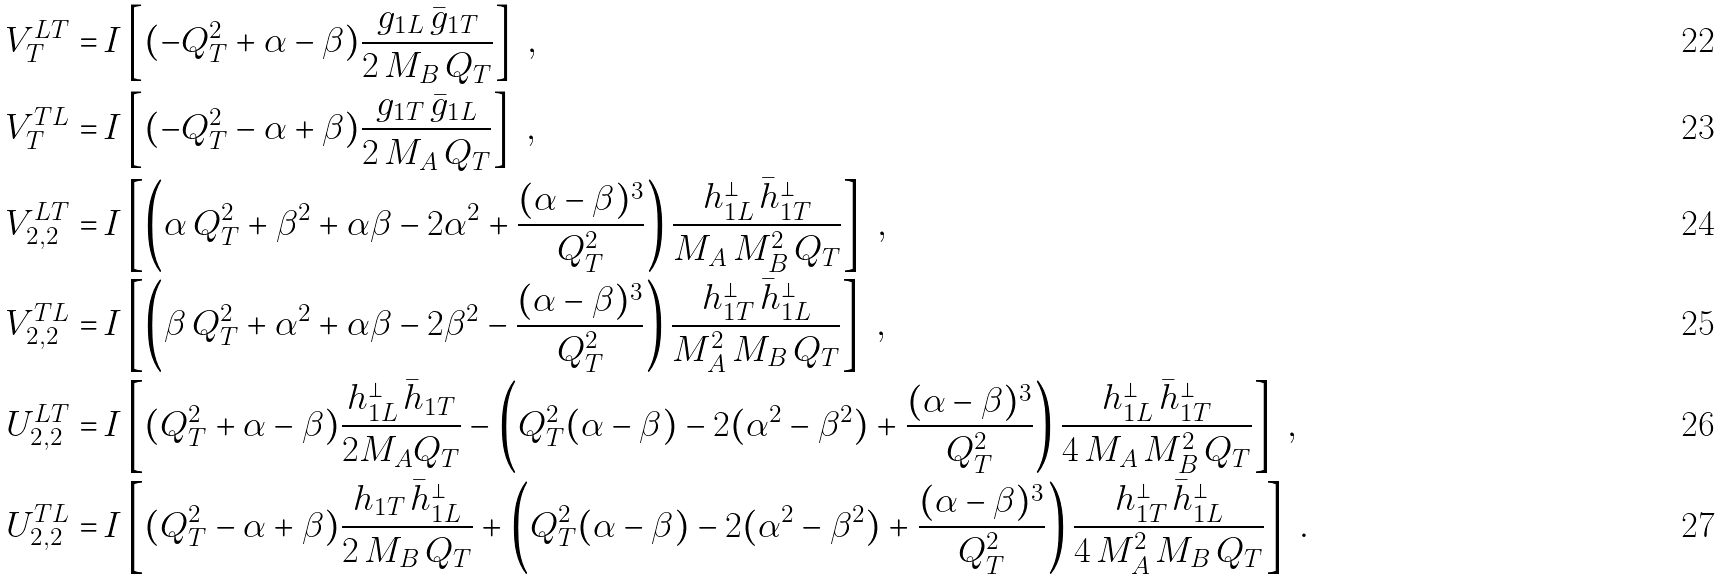<formula> <loc_0><loc_0><loc_500><loc_500>V _ { T } ^ { L T } = & \, I \left [ ( - Q _ { T } ^ { 2 } + \alpha - \beta ) \frac { g _ { 1 L } \, \bar { g } _ { 1 T } } { 2 \, M _ { B } \, Q _ { T } } \right ] \ , \\ V _ { T } ^ { T L } = & \, I \left [ ( - Q _ { T } ^ { 2 } - \alpha + \beta ) \frac { g _ { 1 T } \, \bar { g } _ { 1 L } } { 2 \, M _ { A } \, Q _ { T } } \right ] \ , \\ V _ { 2 , 2 } ^ { L T } = & \, I \left [ \left ( \alpha \, Q _ { T } ^ { 2 } + \beta ^ { 2 } + \alpha \beta - 2 \alpha ^ { 2 } + \frac { ( \alpha - \beta ) ^ { 3 } } { Q _ { T } ^ { 2 } } \right ) \frac { h _ { 1 L } ^ { \perp } \, \bar { h } _ { 1 T } ^ { \perp } } { M _ { A } \, M _ { B } ^ { 2 } \, Q _ { T } } \right ] \ , \\ V _ { 2 , 2 } ^ { T L } = & \, I \left [ \left ( \beta \, Q _ { T } ^ { 2 } + \alpha ^ { 2 } + \alpha \beta - 2 \beta ^ { 2 } - \frac { ( \alpha - \beta ) ^ { 3 } } { Q _ { T } ^ { 2 } } \right ) \frac { h _ { 1 T } ^ { \perp } \, \bar { h } _ { 1 L } ^ { \perp } } { M _ { A } ^ { 2 } \, M _ { B } \, Q _ { T } } \right ] \ , \\ U _ { 2 , 2 } ^ { L T } = & \, I \left [ ( Q _ { T } ^ { 2 } + \alpha - \beta ) \frac { h _ { 1 L } ^ { \perp } \, \bar { h } _ { 1 T } } { 2 M _ { A } Q _ { T } } - \left ( Q _ { T } ^ { 2 } ( \alpha - \beta ) - 2 ( \alpha ^ { 2 } - \beta ^ { 2 } ) + \frac { ( \alpha - \beta ) ^ { 3 } } { Q _ { T } ^ { 2 } } \right ) \frac { h _ { 1 L } ^ { \perp } \, \bar { h } _ { 1 T } ^ { \perp } } { 4 \, M _ { A } \, M _ { B } ^ { 2 } \, Q _ { T } } \right ] \ , \\ U _ { 2 , 2 } ^ { T L } = & \, I \left [ ( Q _ { T } ^ { 2 } - \alpha + \beta ) \frac { h _ { 1 T } \, \bar { h } _ { 1 L } ^ { \perp } } { 2 \, M _ { B } \, Q _ { T } } + \left ( Q _ { T } ^ { 2 } ( \alpha - \beta ) - 2 ( \alpha ^ { 2 } - \beta ^ { 2 } ) + \frac { ( \alpha - \beta ) ^ { 3 } } { Q _ { T } ^ { 2 } } \right ) \frac { h _ { 1 T } ^ { \perp } \, \bar { h } _ { 1 L } ^ { \perp } } { 4 \, M _ { A } ^ { 2 } \, M _ { B } \, Q _ { T } } \right ] \ .</formula> 